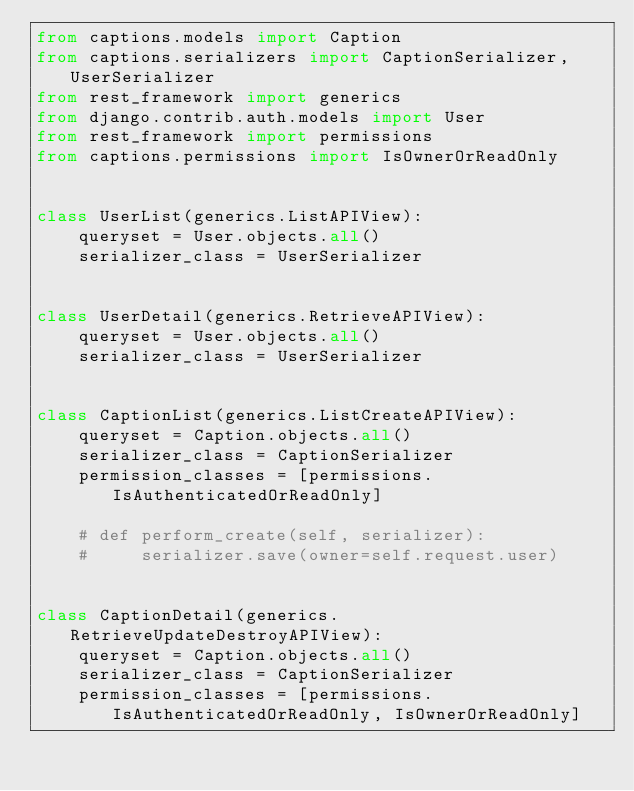<code> <loc_0><loc_0><loc_500><loc_500><_Python_>from captions.models import Caption
from captions.serializers import CaptionSerializer, UserSerializer
from rest_framework import generics
from django.contrib.auth.models import User
from rest_framework import permissions
from captions.permissions import IsOwnerOrReadOnly


class UserList(generics.ListAPIView):
    queryset = User.objects.all()
    serializer_class = UserSerializer


class UserDetail(generics.RetrieveAPIView):
    queryset = User.objects.all()
    serializer_class = UserSerializer


class CaptionList(generics.ListCreateAPIView):
    queryset = Caption.objects.all()
    serializer_class = CaptionSerializer
    permission_classes = [permissions.IsAuthenticatedOrReadOnly]

    # def perform_create(self, serializer):
    #     serializer.save(owner=self.request.user)


class CaptionDetail(generics.RetrieveUpdateDestroyAPIView):
    queryset = Caption.objects.all()
    serializer_class = CaptionSerializer
    permission_classes = [permissions.IsAuthenticatedOrReadOnly, IsOwnerOrReadOnly]
</code> 